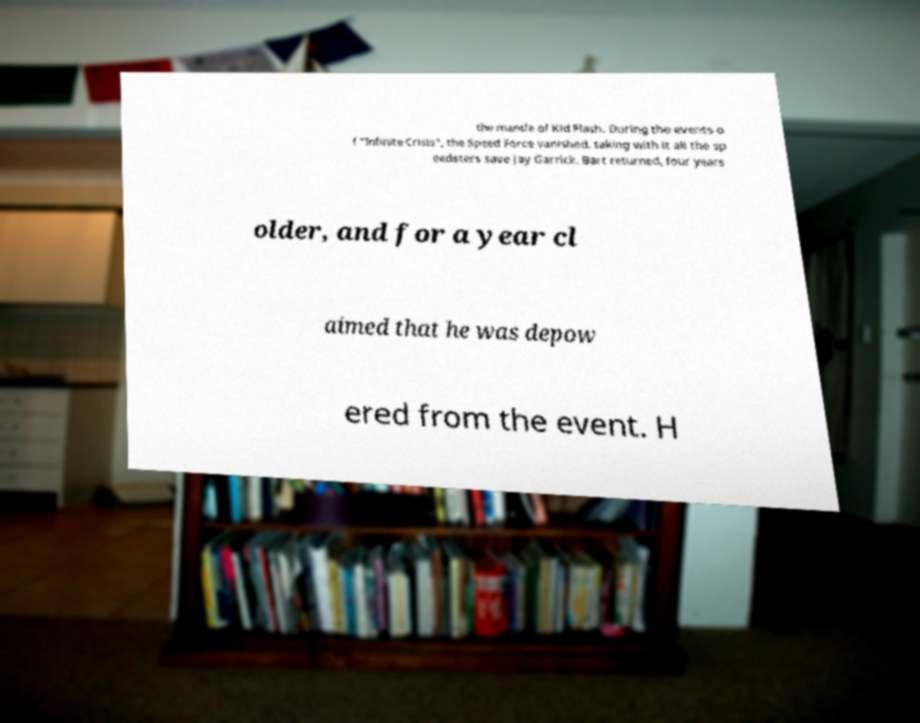For documentation purposes, I need the text within this image transcribed. Could you provide that? the mantle of Kid Flash. During the events o f "Infinite Crisis", the Speed Force vanished, taking with it all the sp eedsters save Jay Garrick. Bart returned, four years older, and for a year cl aimed that he was depow ered from the event. H 